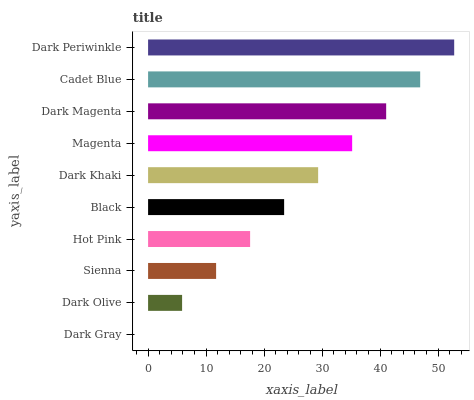Is Dark Gray the minimum?
Answer yes or no. Yes. Is Dark Periwinkle the maximum?
Answer yes or no. Yes. Is Dark Olive the minimum?
Answer yes or no. No. Is Dark Olive the maximum?
Answer yes or no. No. Is Dark Olive greater than Dark Gray?
Answer yes or no. Yes. Is Dark Gray less than Dark Olive?
Answer yes or no. Yes. Is Dark Gray greater than Dark Olive?
Answer yes or no. No. Is Dark Olive less than Dark Gray?
Answer yes or no. No. Is Dark Khaki the high median?
Answer yes or no. Yes. Is Black the low median?
Answer yes or no. Yes. Is Cadet Blue the high median?
Answer yes or no. No. Is Dark Gray the low median?
Answer yes or no. No. 